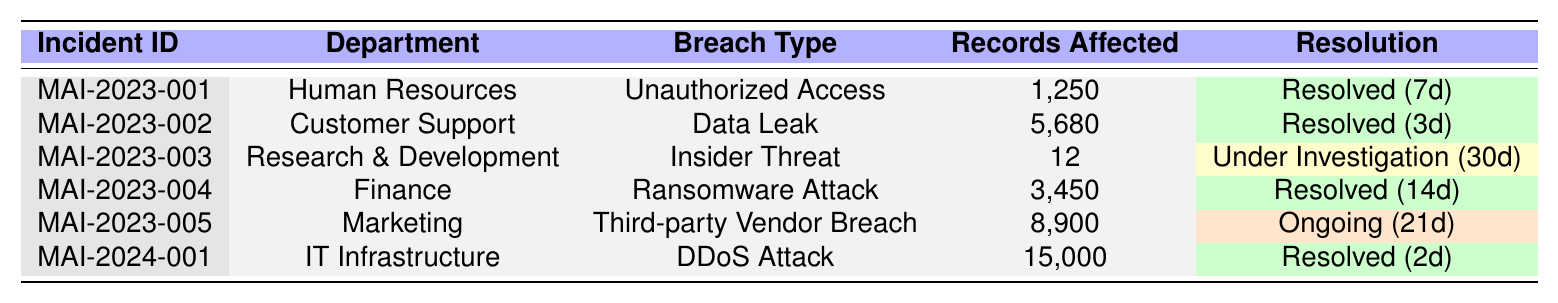What is the most common breach type reported? The table shows the types of breaches reported. The breach types are Unauthorized Access, Data Leak, Insider Threat, Ransomware Attack, Third-party Vendor Breach, and DDoS Attack. The types appear only once except for Ransomware Attack, resulting in a tie.
Answer: No breach type is more common; all appear once Which department had the highest number of records affected? The affected records for each department are listed: Human Resources (1,250), Customer Support (5,680), Research & Development (12), Finance (3,450), Marketing (8,900), and IT Infrastructure (15,000). The department IT Infrastructure had the highest number, with 15,000 records.
Answer: IT Infrastructure How many incidents are currently ongoing? The resolution statuses in the table are inspected: Resolved, Under Investigation, and Ongoing. Only one incident, MAI-2023-005 from Marketing, is marked as Ongoing.
Answer: 1 What is the total number of records affected across all incidents? The records affected from each incident are summed: 1,250 + 5,680 + 12 + 3,450 + 8,900 + 15,000 = 34,292 total records affected across all incidents.
Answer: 34,292 What was the average time taken to resolve the incidents? The days to resolve for each incident are: 7, 3, 30, 14, 21, and 2. The total of these days is 7 + 3 + 30 + 14 + 21 + 2 = 77. There are 6 incidents, so the average is 77 ÷ 6, which is approximately 12.83.
Answer: Approximately 12.83 days Was there any incident under investigation, and if so, which department was it? The resolution statuses indicate that one incident is listed as Under Investigation, which corresponds to the Research & Development department.
Answer: Yes, Research & Development What is the total number of records affected in resolved incidents? The total number of records for resolved incidents are from Human Resources (1,250), Customer Support (5,680), Finance (3,450), and IT Infrastructure (15,000) = 1,250 + 5,680 + 3,450 + 15,000 = 25,380 records affected. The ongoing incident is not counted as resolved.
Answer: 25,380 Which root cause resulted in the highest number of affected records? The root causes with respective affected records are: Phishing Attack (1,250), Misconfigured Database (5,680), Disgruntled Employee (12), Outdated Security Software (3,450), Vendor Security Lapse (8,900), and Inadequate Network Protection (15,000). The highest number of records affected is 15,000 due to the Inadequate Network Protection.
Answer: Inadequate Network Protection Is the incident reported on 2023-05-22 resolved? The table shows that the incident reported on this date corresponds to the breach type Data Leak in the Customer Support department, and its resolution status is marked as Resolved.
Answer: Yes 